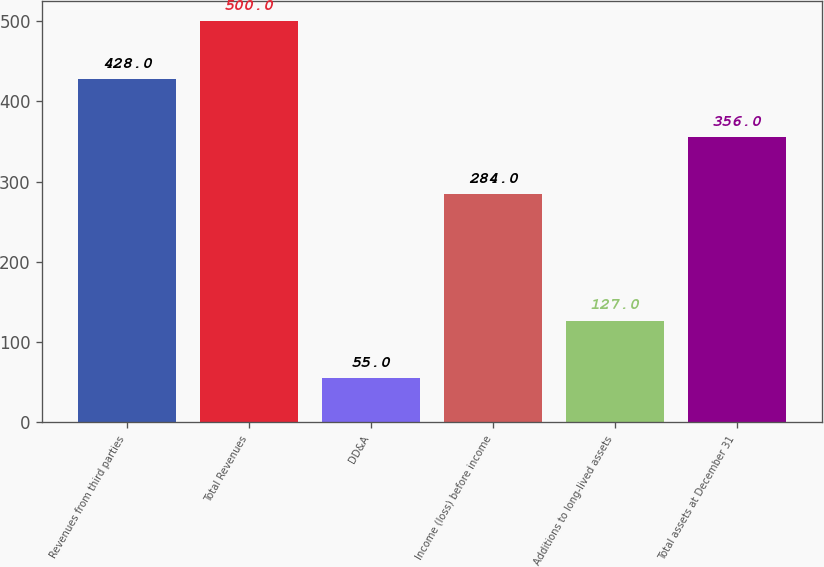<chart> <loc_0><loc_0><loc_500><loc_500><bar_chart><fcel>Revenues from third parties<fcel>Total Revenues<fcel>DD&A<fcel>Income (loss) before income<fcel>Additions to long-lived assets<fcel>Total assets at December 31<nl><fcel>428<fcel>500<fcel>55<fcel>284<fcel>127<fcel>356<nl></chart> 